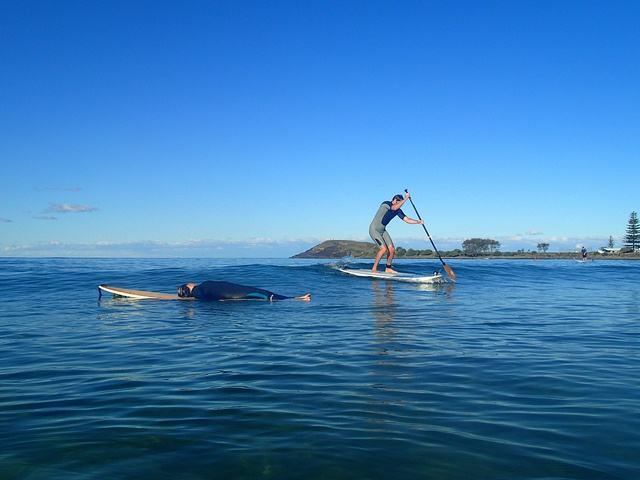Describe the objects in this image and their specific colors. I can see people in blue, navy, black, and gray tones, people in blue, darkgray, navy, salmon, and gray tones, surfboard in blue, navy, darkgray, gray, and tan tones, and surfboard in blue, ivory, darkgray, and gray tones in this image. 